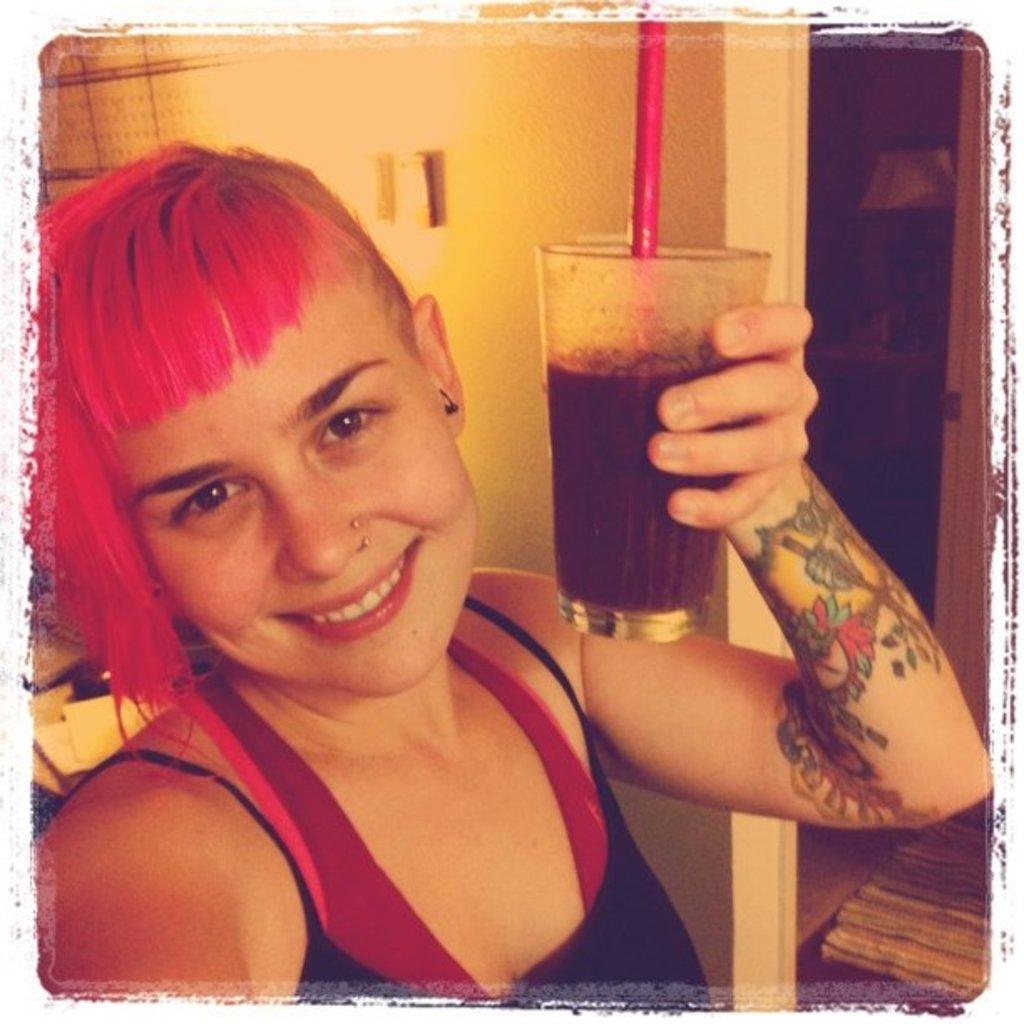Who is present in the image? There is a woman in the image. What is the woman holding in the image? The woman is holding a glass. What color is the wall visible in the image? There is a yellow-colored wall in the image. What type of apparatus is the woman using to solve a riddle in the image? There is no apparatus or riddle present in the image; the woman is simply holding a glass. How many bikes can be seen in the image? There are no bikes present in the image. 